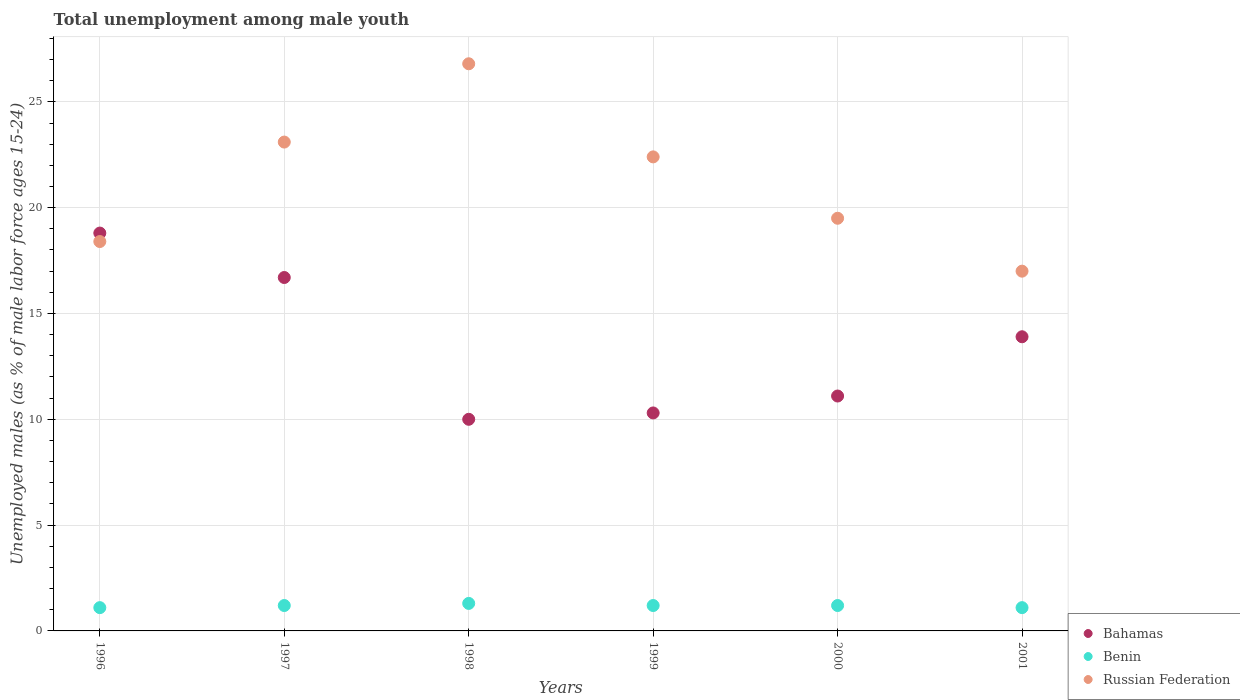How many different coloured dotlines are there?
Provide a succinct answer. 3. What is the percentage of unemployed males in in Russian Federation in 1996?
Provide a succinct answer. 18.4. Across all years, what is the maximum percentage of unemployed males in in Benin?
Your answer should be very brief. 1.3. Across all years, what is the minimum percentage of unemployed males in in Russian Federation?
Offer a very short reply. 17. In which year was the percentage of unemployed males in in Russian Federation minimum?
Offer a terse response. 2001. What is the total percentage of unemployed males in in Benin in the graph?
Give a very brief answer. 7.1. What is the difference between the percentage of unemployed males in in Benin in 1997 and that in 2001?
Your answer should be compact. 0.1. What is the difference between the percentage of unemployed males in in Bahamas in 1997 and the percentage of unemployed males in in Benin in 2000?
Make the answer very short. 15.5. What is the average percentage of unemployed males in in Russian Federation per year?
Make the answer very short. 21.2. In the year 2000, what is the difference between the percentage of unemployed males in in Russian Federation and percentage of unemployed males in in Benin?
Give a very brief answer. 18.3. In how many years, is the percentage of unemployed males in in Bahamas greater than 18 %?
Offer a terse response. 1. What is the ratio of the percentage of unemployed males in in Bahamas in 1996 to that in 2001?
Give a very brief answer. 1.35. Is the percentage of unemployed males in in Russian Federation in 1999 less than that in 2000?
Your answer should be very brief. No. Is the difference between the percentage of unemployed males in in Russian Federation in 1997 and 2001 greater than the difference between the percentage of unemployed males in in Benin in 1997 and 2001?
Provide a short and direct response. Yes. What is the difference between the highest and the second highest percentage of unemployed males in in Bahamas?
Ensure brevity in your answer.  2.1. What is the difference between the highest and the lowest percentage of unemployed males in in Bahamas?
Offer a terse response. 8.8. In how many years, is the percentage of unemployed males in in Benin greater than the average percentage of unemployed males in in Benin taken over all years?
Offer a terse response. 4. Does the percentage of unemployed males in in Russian Federation monotonically increase over the years?
Offer a very short reply. No. How many dotlines are there?
Provide a short and direct response. 3. How many years are there in the graph?
Provide a succinct answer. 6. What is the difference between two consecutive major ticks on the Y-axis?
Keep it short and to the point. 5. Are the values on the major ticks of Y-axis written in scientific E-notation?
Offer a very short reply. No. Does the graph contain any zero values?
Provide a short and direct response. No. Where does the legend appear in the graph?
Your answer should be very brief. Bottom right. How are the legend labels stacked?
Your answer should be very brief. Vertical. What is the title of the graph?
Your answer should be compact. Total unemployment among male youth. Does "Gabon" appear as one of the legend labels in the graph?
Keep it short and to the point. No. What is the label or title of the Y-axis?
Provide a succinct answer. Unemployed males (as % of male labor force ages 15-24). What is the Unemployed males (as % of male labor force ages 15-24) of Bahamas in 1996?
Provide a succinct answer. 18.8. What is the Unemployed males (as % of male labor force ages 15-24) of Benin in 1996?
Ensure brevity in your answer.  1.1. What is the Unemployed males (as % of male labor force ages 15-24) of Russian Federation in 1996?
Give a very brief answer. 18.4. What is the Unemployed males (as % of male labor force ages 15-24) of Bahamas in 1997?
Keep it short and to the point. 16.7. What is the Unemployed males (as % of male labor force ages 15-24) in Benin in 1997?
Provide a succinct answer. 1.2. What is the Unemployed males (as % of male labor force ages 15-24) of Russian Federation in 1997?
Your response must be concise. 23.1. What is the Unemployed males (as % of male labor force ages 15-24) in Bahamas in 1998?
Provide a succinct answer. 10. What is the Unemployed males (as % of male labor force ages 15-24) in Benin in 1998?
Provide a short and direct response. 1.3. What is the Unemployed males (as % of male labor force ages 15-24) in Russian Federation in 1998?
Give a very brief answer. 26.8. What is the Unemployed males (as % of male labor force ages 15-24) of Bahamas in 1999?
Ensure brevity in your answer.  10.3. What is the Unemployed males (as % of male labor force ages 15-24) of Benin in 1999?
Keep it short and to the point. 1.2. What is the Unemployed males (as % of male labor force ages 15-24) of Russian Federation in 1999?
Provide a short and direct response. 22.4. What is the Unemployed males (as % of male labor force ages 15-24) in Bahamas in 2000?
Your response must be concise. 11.1. What is the Unemployed males (as % of male labor force ages 15-24) in Benin in 2000?
Provide a succinct answer. 1.2. What is the Unemployed males (as % of male labor force ages 15-24) in Bahamas in 2001?
Ensure brevity in your answer.  13.9. What is the Unemployed males (as % of male labor force ages 15-24) in Benin in 2001?
Ensure brevity in your answer.  1.1. Across all years, what is the maximum Unemployed males (as % of male labor force ages 15-24) in Bahamas?
Offer a terse response. 18.8. Across all years, what is the maximum Unemployed males (as % of male labor force ages 15-24) in Benin?
Keep it short and to the point. 1.3. Across all years, what is the maximum Unemployed males (as % of male labor force ages 15-24) of Russian Federation?
Provide a succinct answer. 26.8. Across all years, what is the minimum Unemployed males (as % of male labor force ages 15-24) of Bahamas?
Offer a terse response. 10. Across all years, what is the minimum Unemployed males (as % of male labor force ages 15-24) in Benin?
Your answer should be compact. 1.1. What is the total Unemployed males (as % of male labor force ages 15-24) in Bahamas in the graph?
Ensure brevity in your answer.  80.8. What is the total Unemployed males (as % of male labor force ages 15-24) of Benin in the graph?
Make the answer very short. 7.1. What is the total Unemployed males (as % of male labor force ages 15-24) of Russian Federation in the graph?
Provide a succinct answer. 127.2. What is the difference between the Unemployed males (as % of male labor force ages 15-24) of Bahamas in 1996 and that in 1997?
Give a very brief answer. 2.1. What is the difference between the Unemployed males (as % of male labor force ages 15-24) of Benin in 1996 and that in 1997?
Offer a terse response. -0.1. What is the difference between the Unemployed males (as % of male labor force ages 15-24) in Bahamas in 1996 and that in 1998?
Offer a very short reply. 8.8. What is the difference between the Unemployed males (as % of male labor force ages 15-24) in Russian Federation in 1996 and that in 1998?
Give a very brief answer. -8.4. What is the difference between the Unemployed males (as % of male labor force ages 15-24) of Bahamas in 1996 and that in 2000?
Keep it short and to the point. 7.7. What is the difference between the Unemployed males (as % of male labor force ages 15-24) of Benin in 1996 and that in 2000?
Give a very brief answer. -0.1. What is the difference between the Unemployed males (as % of male labor force ages 15-24) in Benin in 1996 and that in 2001?
Your answer should be very brief. 0. What is the difference between the Unemployed males (as % of male labor force ages 15-24) of Russian Federation in 1996 and that in 2001?
Provide a succinct answer. 1.4. What is the difference between the Unemployed males (as % of male labor force ages 15-24) of Bahamas in 1997 and that in 1998?
Offer a very short reply. 6.7. What is the difference between the Unemployed males (as % of male labor force ages 15-24) of Benin in 1997 and that in 1998?
Ensure brevity in your answer.  -0.1. What is the difference between the Unemployed males (as % of male labor force ages 15-24) in Bahamas in 1997 and that in 1999?
Your response must be concise. 6.4. What is the difference between the Unemployed males (as % of male labor force ages 15-24) in Benin in 1997 and that in 1999?
Offer a terse response. 0. What is the difference between the Unemployed males (as % of male labor force ages 15-24) of Benin in 1997 and that in 2000?
Keep it short and to the point. 0. What is the difference between the Unemployed males (as % of male labor force ages 15-24) in Bahamas in 1997 and that in 2001?
Your response must be concise. 2.8. What is the difference between the Unemployed males (as % of male labor force ages 15-24) in Benin in 1997 and that in 2001?
Offer a very short reply. 0.1. What is the difference between the Unemployed males (as % of male labor force ages 15-24) in Benin in 1998 and that in 1999?
Ensure brevity in your answer.  0.1. What is the difference between the Unemployed males (as % of male labor force ages 15-24) in Benin in 1998 and that in 2000?
Offer a very short reply. 0.1. What is the difference between the Unemployed males (as % of male labor force ages 15-24) of Russian Federation in 1998 and that in 2000?
Your answer should be very brief. 7.3. What is the difference between the Unemployed males (as % of male labor force ages 15-24) in Russian Federation in 1998 and that in 2001?
Make the answer very short. 9.8. What is the difference between the Unemployed males (as % of male labor force ages 15-24) of Bahamas in 1999 and that in 2000?
Provide a short and direct response. -0.8. What is the difference between the Unemployed males (as % of male labor force ages 15-24) of Russian Federation in 2000 and that in 2001?
Your answer should be compact. 2.5. What is the difference between the Unemployed males (as % of male labor force ages 15-24) of Bahamas in 1996 and the Unemployed males (as % of male labor force ages 15-24) of Benin in 1998?
Your response must be concise. 17.5. What is the difference between the Unemployed males (as % of male labor force ages 15-24) of Bahamas in 1996 and the Unemployed males (as % of male labor force ages 15-24) of Russian Federation in 1998?
Your answer should be compact. -8. What is the difference between the Unemployed males (as % of male labor force ages 15-24) in Benin in 1996 and the Unemployed males (as % of male labor force ages 15-24) in Russian Federation in 1998?
Ensure brevity in your answer.  -25.7. What is the difference between the Unemployed males (as % of male labor force ages 15-24) of Bahamas in 1996 and the Unemployed males (as % of male labor force ages 15-24) of Benin in 1999?
Your response must be concise. 17.6. What is the difference between the Unemployed males (as % of male labor force ages 15-24) of Benin in 1996 and the Unemployed males (as % of male labor force ages 15-24) of Russian Federation in 1999?
Ensure brevity in your answer.  -21.3. What is the difference between the Unemployed males (as % of male labor force ages 15-24) in Benin in 1996 and the Unemployed males (as % of male labor force ages 15-24) in Russian Federation in 2000?
Give a very brief answer. -18.4. What is the difference between the Unemployed males (as % of male labor force ages 15-24) in Bahamas in 1996 and the Unemployed males (as % of male labor force ages 15-24) in Benin in 2001?
Provide a short and direct response. 17.7. What is the difference between the Unemployed males (as % of male labor force ages 15-24) in Bahamas in 1996 and the Unemployed males (as % of male labor force ages 15-24) in Russian Federation in 2001?
Offer a very short reply. 1.8. What is the difference between the Unemployed males (as % of male labor force ages 15-24) in Benin in 1996 and the Unemployed males (as % of male labor force ages 15-24) in Russian Federation in 2001?
Give a very brief answer. -15.9. What is the difference between the Unemployed males (as % of male labor force ages 15-24) of Benin in 1997 and the Unemployed males (as % of male labor force ages 15-24) of Russian Federation in 1998?
Offer a terse response. -25.6. What is the difference between the Unemployed males (as % of male labor force ages 15-24) of Bahamas in 1997 and the Unemployed males (as % of male labor force ages 15-24) of Benin in 1999?
Your response must be concise. 15.5. What is the difference between the Unemployed males (as % of male labor force ages 15-24) in Benin in 1997 and the Unemployed males (as % of male labor force ages 15-24) in Russian Federation in 1999?
Provide a short and direct response. -21.2. What is the difference between the Unemployed males (as % of male labor force ages 15-24) in Benin in 1997 and the Unemployed males (as % of male labor force ages 15-24) in Russian Federation in 2000?
Keep it short and to the point. -18.3. What is the difference between the Unemployed males (as % of male labor force ages 15-24) in Bahamas in 1997 and the Unemployed males (as % of male labor force ages 15-24) in Russian Federation in 2001?
Provide a short and direct response. -0.3. What is the difference between the Unemployed males (as % of male labor force ages 15-24) of Benin in 1997 and the Unemployed males (as % of male labor force ages 15-24) of Russian Federation in 2001?
Keep it short and to the point. -15.8. What is the difference between the Unemployed males (as % of male labor force ages 15-24) of Benin in 1998 and the Unemployed males (as % of male labor force ages 15-24) of Russian Federation in 1999?
Keep it short and to the point. -21.1. What is the difference between the Unemployed males (as % of male labor force ages 15-24) in Bahamas in 1998 and the Unemployed males (as % of male labor force ages 15-24) in Benin in 2000?
Your response must be concise. 8.8. What is the difference between the Unemployed males (as % of male labor force ages 15-24) of Bahamas in 1998 and the Unemployed males (as % of male labor force ages 15-24) of Russian Federation in 2000?
Ensure brevity in your answer.  -9.5. What is the difference between the Unemployed males (as % of male labor force ages 15-24) of Benin in 1998 and the Unemployed males (as % of male labor force ages 15-24) of Russian Federation in 2000?
Your response must be concise. -18.2. What is the difference between the Unemployed males (as % of male labor force ages 15-24) in Bahamas in 1998 and the Unemployed males (as % of male labor force ages 15-24) in Benin in 2001?
Your answer should be very brief. 8.9. What is the difference between the Unemployed males (as % of male labor force ages 15-24) in Benin in 1998 and the Unemployed males (as % of male labor force ages 15-24) in Russian Federation in 2001?
Offer a very short reply. -15.7. What is the difference between the Unemployed males (as % of male labor force ages 15-24) of Bahamas in 1999 and the Unemployed males (as % of male labor force ages 15-24) of Russian Federation in 2000?
Ensure brevity in your answer.  -9.2. What is the difference between the Unemployed males (as % of male labor force ages 15-24) in Benin in 1999 and the Unemployed males (as % of male labor force ages 15-24) in Russian Federation in 2000?
Ensure brevity in your answer.  -18.3. What is the difference between the Unemployed males (as % of male labor force ages 15-24) of Bahamas in 1999 and the Unemployed males (as % of male labor force ages 15-24) of Benin in 2001?
Make the answer very short. 9.2. What is the difference between the Unemployed males (as % of male labor force ages 15-24) of Bahamas in 1999 and the Unemployed males (as % of male labor force ages 15-24) of Russian Federation in 2001?
Ensure brevity in your answer.  -6.7. What is the difference between the Unemployed males (as % of male labor force ages 15-24) of Benin in 1999 and the Unemployed males (as % of male labor force ages 15-24) of Russian Federation in 2001?
Make the answer very short. -15.8. What is the difference between the Unemployed males (as % of male labor force ages 15-24) of Bahamas in 2000 and the Unemployed males (as % of male labor force ages 15-24) of Benin in 2001?
Offer a very short reply. 10. What is the difference between the Unemployed males (as % of male labor force ages 15-24) in Benin in 2000 and the Unemployed males (as % of male labor force ages 15-24) in Russian Federation in 2001?
Offer a terse response. -15.8. What is the average Unemployed males (as % of male labor force ages 15-24) in Bahamas per year?
Provide a short and direct response. 13.47. What is the average Unemployed males (as % of male labor force ages 15-24) of Benin per year?
Keep it short and to the point. 1.18. What is the average Unemployed males (as % of male labor force ages 15-24) in Russian Federation per year?
Give a very brief answer. 21.2. In the year 1996, what is the difference between the Unemployed males (as % of male labor force ages 15-24) of Benin and Unemployed males (as % of male labor force ages 15-24) of Russian Federation?
Make the answer very short. -17.3. In the year 1997, what is the difference between the Unemployed males (as % of male labor force ages 15-24) in Bahamas and Unemployed males (as % of male labor force ages 15-24) in Benin?
Ensure brevity in your answer.  15.5. In the year 1997, what is the difference between the Unemployed males (as % of male labor force ages 15-24) of Benin and Unemployed males (as % of male labor force ages 15-24) of Russian Federation?
Your response must be concise. -21.9. In the year 1998, what is the difference between the Unemployed males (as % of male labor force ages 15-24) of Bahamas and Unemployed males (as % of male labor force ages 15-24) of Russian Federation?
Keep it short and to the point. -16.8. In the year 1998, what is the difference between the Unemployed males (as % of male labor force ages 15-24) of Benin and Unemployed males (as % of male labor force ages 15-24) of Russian Federation?
Provide a short and direct response. -25.5. In the year 1999, what is the difference between the Unemployed males (as % of male labor force ages 15-24) in Bahamas and Unemployed males (as % of male labor force ages 15-24) in Russian Federation?
Offer a terse response. -12.1. In the year 1999, what is the difference between the Unemployed males (as % of male labor force ages 15-24) in Benin and Unemployed males (as % of male labor force ages 15-24) in Russian Federation?
Your answer should be compact. -21.2. In the year 2000, what is the difference between the Unemployed males (as % of male labor force ages 15-24) of Benin and Unemployed males (as % of male labor force ages 15-24) of Russian Federation?
Offer a terse response. -18.3. In the year 2001, what is the difference between the Unemployed males (as % of male labor force ages 15-24) in Bahamas and Unemployed males (as % of male labor force ages 15-24) in Benin?
Make the answer very short. 12.8. In the year 2001, what is the difference between the Unemployed males (as % of male labor force ages 15-24) of Benin and Unemployed males (as % of male labor force ages 15-24) of Russian Federation?
Make the answer very short. -15.9. What is the ratio of the Unemployed males (as % of male labor force ages 15-24) in Bahamas in 1996 to that in 1997?
Your answer should be very brief. 1.13. What is the ratio of the Unemployed males (as % of male labor force ages 15-24) of Benin in 1996 to that in 1997?
Your answer should be very brief. 0.92. What is the ratio of the Unemployed males (as % of male labor force ages 15-24) of Russian Federation in 1996 to that in 1997?
Make the answer very short. 0.8. What is the ratio of the Unemployed males (as % of male labor force ages 15-24) in Bahamas in 1996 to that in 1998?
Your answer should be very brief. 1.88. What is the ratio of the Unemployed males (as % of male labor force ages 15-24) in Benin in 1996 to that in 1998?
Offer a terse response. 0.85. What is the ratio of the Unemployed males (as % of male labor force ages 15-24) of Russian Federation in 1996 to that in 1998?
Your answer should be very brief. 0.69. What is the ratio of the Unemployed males (as % of male labor force ages 15-24) of Bahamas in 1996 to that in 1999?
Your answer should be very brief. 1.83. What is the ratio of the Unemployed males (as % of male labor force ages 15-24) of Benin in 1996 to that in 1999?
Your response must be concise. 0.92. What is the ratio of the Unemployed males (as % of male labor force ages 15-24) in Russian Federation in 1996 to that in 1999?
Keep it short and to the point. 0.82. What is the ratio of the Unemployed males (as % of male labor force ages 15-24) of Bahamas in 1996 to that in 2000?
Offer a very short reply. 1.69. What is the ratio of the Unemployed males (as % of male labor force ages 15-24) in Benin in 1996 to that in 2000?
Keep it short and to the point. 0.92. What is the ratio of the Unemployed males (as % of male labor force ages 15-24) of Russian Federation in 1996 to that in 2000?
Give a very brief answer. 0.94. What is the ratio of the Unemployed males (as % of male labor force ages 15-24) in Bahamas in 1996 to that in 2001?
Your answer should be compact. 1.35. What is the ratio of the Unemployed males (as % of male labor force ages 15-24) in Russian Federation in 1996 to that in 2001?
Provide a succinct answer. 1.08. What is the ratio of the Unemployed males (as % of male labor force ages 15-24) in Bahamas in 1997 to that in 1998?
Offer a very short reply. 1.67. What is the ratio of the Unemployed males (as % of male labor force ages 15-24) of Benin in 1997 to that in 1998?
Provide a short and direct response. 0.92. What is the ratio of the Unemployed males (as % of male labor force ages 15-24) of Russian Federation in 1997 to that in 1998?
Your response must be concise. 0.86. What is the ratio of the Unemployed males (as % of male labor force ages 15-24) of Bahamas in 1997 to that in 1999?
Your answer should be compact. 1.62. What is the ratio of the Unemployed males (as % of male labor force ages 15-24) of Russian Federation in 1997 to that in 1999?
Make the answer very short. 1.03. What is the ratio of the Unemployed males (as % of male labor force ages 15-24) in Bahamas in 1997 to that in 2000?
Your answer should be very brief. 1.5. What is the ratio of the Unemployed males (as % of male labor force ages 15-24) in Russian Federation in 1997 to that in 2000?
Your response must be concise. 1.18. What is the ratio of the Unemployed males (as % of male labor force ages 15-24) of Bahamas in 1997 to that in 2001?
Make the answer very short. 1.2. What is the ratio of the Unemployed males (as % of male labor force ages 15-24) in Benin in 1997 to that in 2001?
Ensure brevity in your answer.  1.09. What is the ratio of the Unemployed males (as % of male labor force ages 15-24) in Russian Federation in 1997 to that in 2001?
Your response must be concise. 1.36. What is the ratio of the Unemployed males (as % of male labor force ages 15-24) in Bahamas in 1998 to that in 1999?
Your answer should be compact. 0.97. What is the ratio of the Unemployed males (as % of male labor force ages 15-24) in Russian Federation in 1998 to that in 1999?
Your answer should be compact. 1.2. What is the ratio of the Unemployed males (as % of male labor force ages 15-24) of Bahamas in 1998 to that in 2000?
Provide a succinct answer. 0.9. What is the ratio of the Unemployed males (as % of male labor force ages 15-24) in Russian Federation in 1998 to that in 2000?
Your answer should be compact. 1.37. What is the ratio of the Unemployed males (as % of male labor force ages 15-24) in Bahamas in 1998 to that in 2001?
Give a very brief answer. 0.72. What is the ratio of the Unemployed males (as % of male labor force ages 15-24) in Benin in 1998 to that in 2001?
Make the answer very short. 1.18. What is the ratio of the Unemployed males (as % of male labor force ages 15-24) in Russian Federation in 1998 to that in 2001?
Your answer should be very brief. 1.58. What is the ratio of the Unemployed males (as % of male labor force ages 15-24) of Bahamas in 1999 to that in 2000?
Make the answer very short. 0.93. What is the ratio of the Unemployed males (as % of male labor force ages 15-24) of Russian Federation in 1999 to that in 2000?
Ensure brevity in your answer.  1.15. What is the ratio of the Unemployed males (as % of male labor force ages 15-24) in Bahamas in 1999 to that in 2001?
Provide a short and direct response. 0.74. What is the ratio of the Unemployed males (as % of male labor force ages 15-24) of Russian Federation in 1999 to that in 2001?
Provide a succinct answer. 1.32. What is the ratio of the Unemployed males (as % of male labor force ages 15-24) in Bahamas in 2000 to that in 2001?
Provide a succinct answer. 0.8. What is the ratio of the Unemployed males (as % of male labor force ages 15-24) of Benin in 2000 to that in 2001?
Keep it short and to the point. 1.09. What is the ratio of the Unemployed males (as % of male labor force ages 15-24) of Russian Federation in 2000 to that in 2001?
Make the answer very short. 1.15. What is the difference between the highest and the second highest Unemployed males (as % of male labor force ages 15-24) of Bahamas?
Offer a very short reply. 2.1. What is the difference between the highest and the second highest Unemployed males (as % of male labor force ages 15-24) in Benin?
Give a very brief answer. 0.1. 